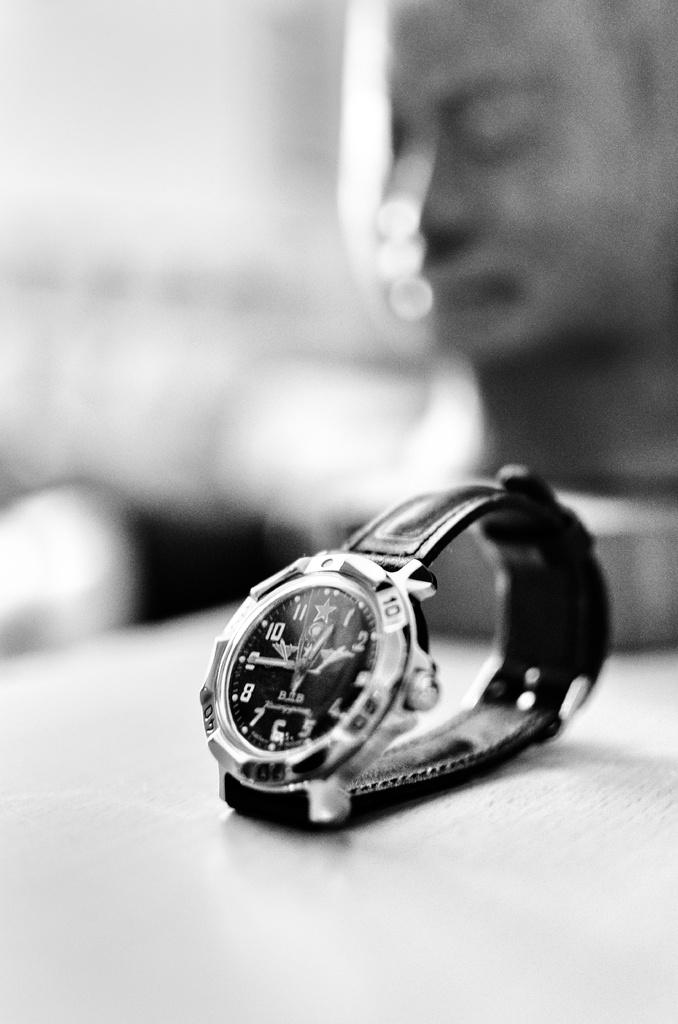<image>
Summarize the visual content of the image. black and silver watch with the hands at 1 and 9. 